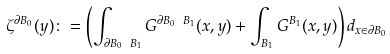<formula> <loc_0><loc_0><loc_500><loc_500>\zeta ^ { \partial B _ { 0 } } ( y ) \colon = \left ( \int _ { \partial B _ { 0 } \ B _ { 1 } } G ^ { \partial B _ { 0 } \ B _ { 1 } } ( x , y ) + \int _ { B _ { 1 } } G ^ { B _ { 1 } } ( x , y ) \right ) d _ { x \in \partial B _ { 0 } }</formula> 